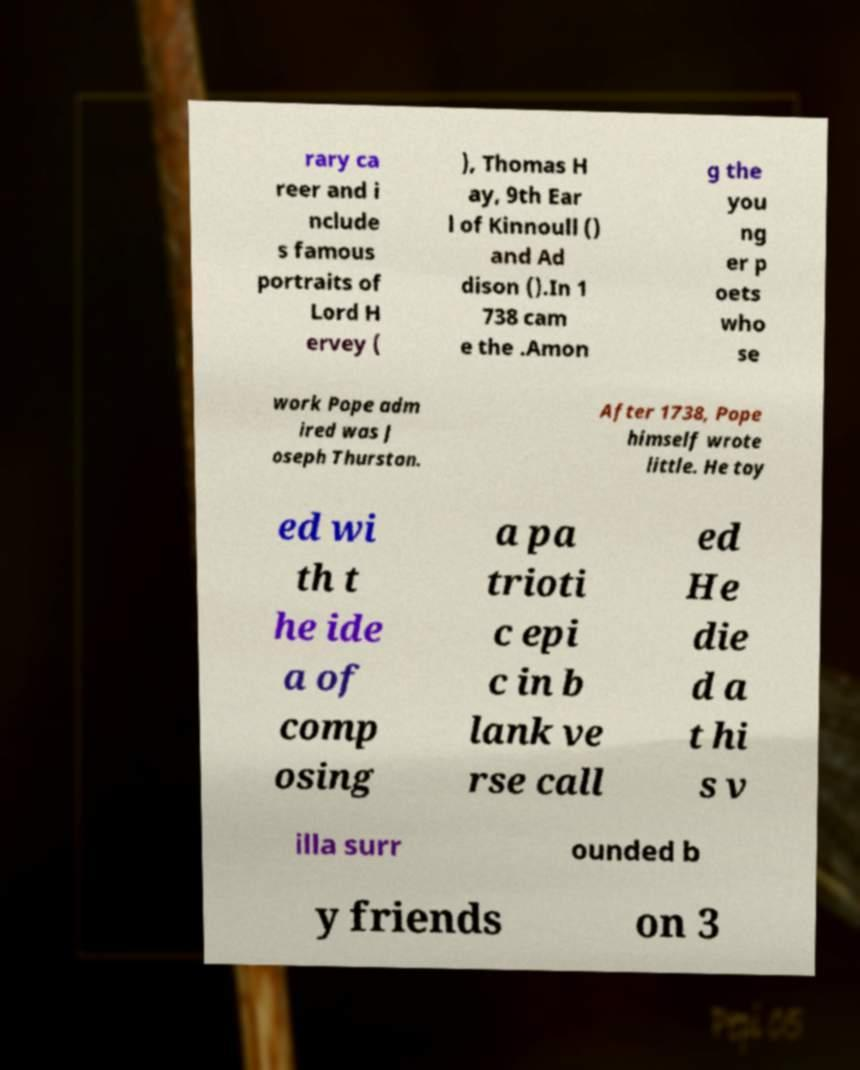Please read and relay the text visible in this image. What does it say? rary ca reer and i nclude s famous portraits of Lord H ervey ( ), Thomas H ay, 9th Ear l of Kinnoull () and Ad dison ().In 1 738 cam e the .Amon g the you ng er p oets who se work Pope adm ired was J oseph Thurston. After 1738, Pope himself wrote little. He toy ed wi th t he ide a of comp osing a pa trioti c epi c in b lank ve rse call ed He die d a t hi s v illa surr ounded b y friends on 3 